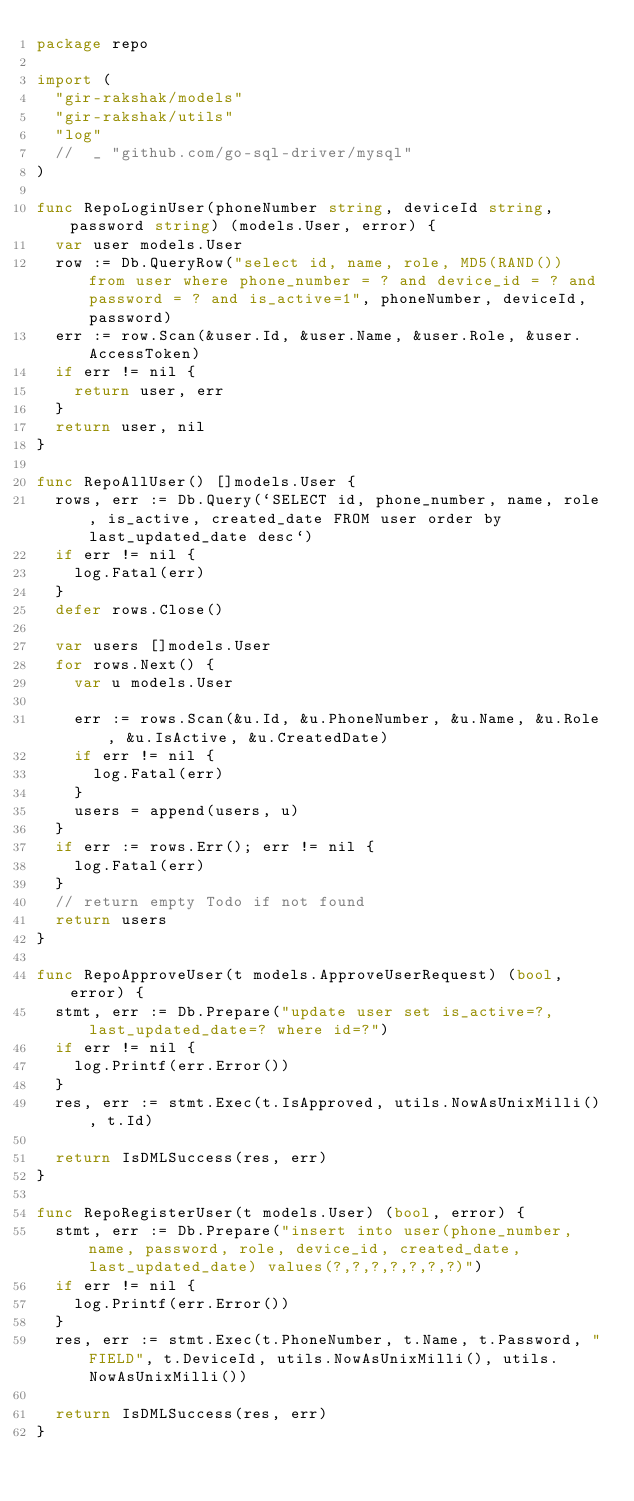<code> <loc_0><loc_0><loc_500><loc_500><_Go_>package repo

import (
	"gir-rakshak/models"
	"gir-rakshak/utils"
	"log"
	//	_ "github.com/go-sql-driver/mysql"
)

func RepoLoginUser(phoneNumber string, deviceId string, password string) (models.User, error) {
	var user models.User
	row := Db.QueryRow("select id, name, role, MD5(RAND()) from user where phone_number = ? and device_id = ? and password = ? and is_active=1", phoneNumber, deviceId, password)
	err := row.Scan(&user.Id, &user.Name, &user.Role, &user.AccessToken)
	if err != nil {
		return user, err
	}
	return user, nil
}

func RepoAllUser() []models.User {
	rows, err := Db.Query(`SELECT id, phone_number, name, role, is_active, created_date FROM user order by last_updated_date desc`)
	if err != nil {
		log.Fatal(err)
	}
	defer rows.Close()

	var users []models.User
	for rows.Next() {
		var u models.User

		err := rows.Scan(&u.Id, &u.PhoneNumber, &u.Name, &u.Role, &u.IsActive, &u.CreatedDate)
		if err != nil {
			log.Fatal(err)
		}
		users = append(users, u)
	}
	if err := rows.Err(); err != nil {
		log.Fatal(err)
	}
	// return empty Todo if not found
	return users
}

func RepoApproveUser(t models.ApproveUserRequest) (bool, error) {
	stmt, err := Db.Prepare("update user set is_active=?, last_updated_date=? where id=?")
	if err != nil {
		log.Printf(err.Error())
	}
	res, err := stmt.Exec(t.IsApproved, utils.NowAsUnixMilli(), t.Id)

	return IsDMLSuccess(res, err)
}

func RepoRegisterUser(t models.User) (bool, error) {
	stmt, err := Db.Prepare("insert into user(phone_number, name, password, role, device_id, created_date, last_updated_date) values(?,?,?,?,?,?,?)")
	if err != nil {
		log.Printf(err.Error())
	}
	res, err := stmt.Exec(t.PhoneNumber, t.Name, t.Password, "FIELD", t.DeviceId, utils.NowAsUnixMilli(), utils.NowAsUnixMilli())

	return IsDMLSuccess(res, err)
}
</code> 